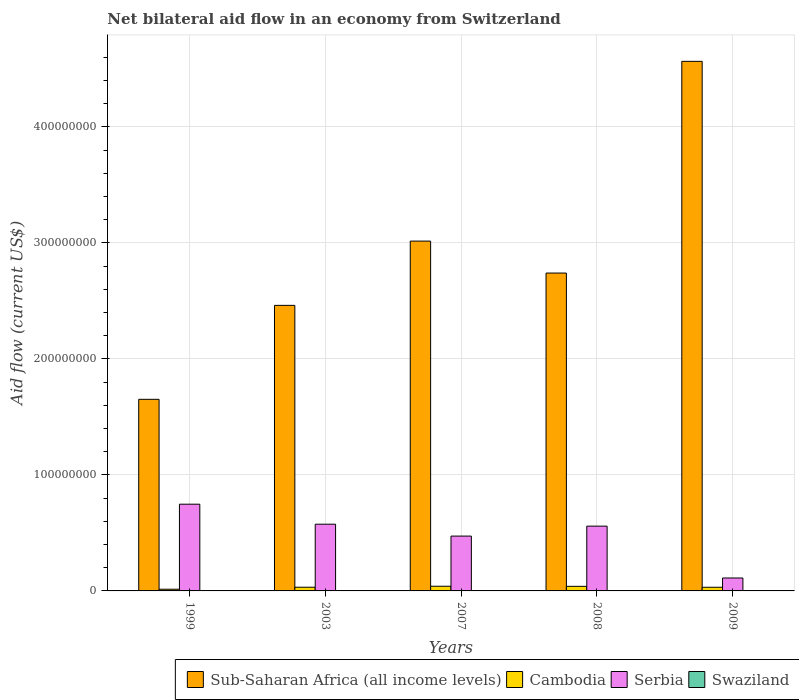How many different coloured bars are there?
Your answer should be very brief. 4. How many groups of bars are there?
Make the answer very short. 5. Are the number of bars per tick equal to the number of legend labels?
Your answer should be compact. Yes. Are the number of bars on each tick of the X-axis equal?
Keep it short and to the point. Yes. How many bars are there on the 5th tick from the left?
Provide a succinct answer. 4. What is the label of the 2nd group of bars from the left?
Give a very brief answer. 2003. What is the net bilateral aid flow in Serbia in 2007?
Make the answer very short. 4.73e+07. Across all years, what is the maximum net bilateral aid flow in Cambodia?
Keep it short and to the point. 4.03e+06. Across all years, what is the minimum net bilateral aid flow in Swaziland?
Offer a terse response. 2.00e+04. In which year was the net bilateral aid flow in Swaziland maximum?
Your answer should be compact. 2008. In which year was the net bilateral aid flow in Sub-Saharan Africa (all income levels) minimum?
Offer a terse response. 1999. What is the total net bilateral aid flow in Sub-Saharan Africa (all income levels) in the graph?
Offer a very short reply. 1.44e+09. What is the difference between the net bilateral aid flow in Cambodia in 2007 and that in 2009?
Your answer should be very brief. 8.70e+05. What is the difference between the net bilateral aid flow in Sub-Saharan Africa (all income levels) in 2003 and the net bilateral aid flow in Serbia in 1999?
Your answer should be very brief. 1.71e+08. What is the average net bilateral aid flow in Cambodia per year?
Your answer should be very brief. 3.16e+06. In the year 2003, what is the difference between the net bilateral aid flow in Sub-Saharan Africa (all income levels) and net bilateral aid flow in Swaziland?
Provide a succinct answer. 2.46e+08. What is the ratio of the net bilateral aid flow in Serbia in 2003 to that in 2007?
Keep it short and to the point. 1.22. In how many years, is the net bilateral aid flow in Sub-Saharan Africa (all income levels) greater than the average net bilateral aid flow in Sub-Saharan Africa (all income levels) taken over all years?
Provide a short and direct response. 2. Is the sum of the net bilateral aid flow in Swaziland in 1999 and 2009 greater than the maximum net bilateral aid flow in Cambodia across all years?
Your answer should be very brief. No. Is it the case that in every year, the sum of the net bilateral aid flow in Sub-Saharan Africa (all income levels) and net bilateral aid flow in Cambodia is greater than the sum of net bilateral aid flow in Serbia and net bilateral aid flow in Swaziland?
Offer a very short reply. Yes. What does the 3rd bar from the left in 2008 represents?
Offer a terse response. Serbia. What does the 3rd bar from the right in 2008 represents?
Offer a very short reply. Cambodia. How many bars are there?
Offer a very short reply. 20. Does the graph contain any zero values?
Give a very brief answer. No. Does the graph contain grids?
Ensure brevity in your answer.  Yes. How many legend labels are there?
Keep it short and to the point. 4. How are the legend labels stacked?
Provide a succinct answer. Horizontal. What is the title of the graph?
Your answer should be very brief. Net bilateral aid flow in an economy from Switzerland. What is the label or title of the X-axis?
Your answer should be very brief. Years. What is the Aid flow (current US$) of Sub-Saharan Africa (all income levels) in 1999?
Your answer should be very brief. 1.65e+08. What is the Aid flow (current US$) in Cambodia in 1999?
Offer a very short reply. 1.46e+06. What is the Aid flow (current US$) in Serbia in 1999?
Provide a short and direct response. 7.48e+07. What is the Aid flow (current US$) of Sub-Saharan Africa (all income levels) in 2003?
Offer a very short reply. 2.46e+08. What is the Aid flow (current US$) in Cambodia in 2003?
Make the answer very short. 3.19e+06. What is the Aid flow (current US$) in Serbia in 2003?
Give a very brief answer. 5.75e+07. What is the Aid flow (current US$) in Swaziland in 2003?
Your answer should be compact. 7.00e+04. What is the Aid flow (current US$) in Sub-Saharan Africa (all income levels) in 2007?
Your answer should be compact. 3.02e+08. What is the Aid flow (current US$) of Cambodia in 2007?
Provide a succinct answer. 4.03e+06. What is the Aid flow (current US$) in Serbia in 2007?
Keep it short and to the point. 4.73e+07. What is the Aid flow (current US$) in Swaziland in 2007?
Keep it short and to the point. 2.00e+04. What is the Aid flow (current US$) in Sub-Saharan Africa (all income levels) in 2008?
Provide a succinct answer. 2.74e+08. What is the Aid flow (current US$) in Cambodia in 2008?
Offer a terse response. 3.95e+06. What is the Aid flow (current US$) in Serbia in 2008?
Keep it short and to the point. 5.58e+07. What is the Aid flow (current US$) of Sub-Saharan Africa (all income levels) in 2009?
Your response must be concise. 4.56e+08. What is the Aid flow (current US$) of Cambodia in 2009?
Provide a succinct answer. 3.16e+06. What is the Aid flow (current US$) of Serbia in 2009?
Offer a terse response. 1.12e+07. What is the Aid flow (current US$) of Swaziland in 2009?
Offer a terse response. 2.00e+04. Across all years, what is the maximum Aid flow (current US$) of Sub-Saharan Africa (all income levels)?
Your answer should be compact. 4.56e+08. Across all years, what is the maximum Aid flow (current US$) in Cambodia?
Your answer should be very brief. 4.03e+06. Across all years, what is the maximum Aid flow (current US$) in Serbia?
Ensure brevity in your answer.  7.48e+07. Across all years, what is the maximum Aid flow (current US$) of Swaziland?
Offer a very short reply. 1.40e+05. Across all years, what is the minimum Aid flow (current US$) of Sub-Saharan Africa (all income levels)?
Your response must be concise. 1.65e+08. Across all years, what is the minimum Aid flow (current US$) in Cambodia?
Give a very brief answer. 1.46e+06. Across all years, what is the minimum Aid flow (current US$) of Serbia?
Make the answer very short. 1.12e+07. What is the total Aid flow (current US$) of Sub-Saharan Africa (all income levels) in the graph?
Your response must be concise. 1.44e+09. What is the total Aid flow (current US$) of Cambodia in the graph?
Provide a short and direct response. 1.58e+07. What is the total Aid flow (current US$) of Serbia in the graph?
Your response must be concise. 2.47e+08. What is the difference between the Aid flow (current US$) in Sub-Saharan Africa (all income levels) in 1999 and that in 2003?
Give a very brief answer. -8.10e+07. What is the difference between the Aid flow (current US$) of Cambodia in 1999 and that in 2003?
Make the answer very short. -1.73e+06. What is the difference between the Aid flow (current US$) of Serbia in 1999 and that in 2003?
Your answer should be compact. 1.72e+07. What is the difference between the Aid flow (current US$) in Sub-Saharan Africa (all income levels) in 1999 and that in 2007?
Your answer should be compact. -1.36e+08. What is the difference between the Aid flow (current US$) of Cambodia in 1999 and that in 2007?
Give a very brief answer. -2.57e+06. What is the difference between the Aid flow (current US$) in Serbia in 1999 and that in 2007?
Your answer should be compact. 2.75e+07. What is the difference between the Aid flow (current US$) of Sub-Saharan Africa (all income levels) in 1999 and that in 2008?
Your answer should be very brief. -1.09e+08. What is the difference between the Aid flow (current US$) of Cambodia in 1999 and that in 2008?
Your response must be concise. -2.49e+06. What is the difference between the Aid flow (current US$) of Serbia in 1999 and that in 2008?
Your answer should be compact. 1.89e+07. What is the difference between the Aid flow (current US$) in Swaziland in 1999 and that in 2008?
Give a very brief answer. -1.00e+05. What is the difference between the Aid flow (current US$) of Sub-Saharan Africa (all income levels) in 1999 and that in 2009?
Give a very brief answer. -2.91e+08. What is the difference between the Aid flow (current US$) of Cambodia in 1999 and that in 2009?
Make the answer very short. -1.70e+06. What is the difference between the Aid flow (current US$) in Serbia in 1999 and that in 2009?
Your answer should be very brief. 6.36e+07. What is the difference between the Aid flow (current US$) in Swaziland in 1999 and that in 2009?
Keep it short and to the point. 2.00e+04. What is the difference between the Aid flow (current US$) in Sub-Saharan Africa (all income levels) in 2003 and that in 2007?
Offer a very short reply. -5.54e+07. What is the difference between the Aid flow (current US$) of Cambodia in 2003 and that in 2007?
Your answer should be very brief. -8.40e+05. What is the difference between the Aid flow (current US$) in Serbia in 2003 and that in 2007?
Your answer should be compact. 1.02e+07. What is the difference between the Aid flow (current US$) in Swaziland in 2003 and that in 2007?
Offer a terse response. 5.00e+04. What is the difference between the Aid flow (current US$) in Sub-Saharan Africa (all income levels) in 2003 and that in 2008?
Keep it short and to the point. -2.79e+07. What is the difference between the Aid flow (current US$) of Cambodia in 2003 and that in 2008?
Ensure brevity in your answer.  -7.60e+05. What is the difference between the Aid flow (current US$) in Serbia in 2003 and that in 2008?
Offer a very short reply. 1.67e+06. What is the difference between the Aid flow (current US$) in Swaziland in 2003 and that in 2008?
Provide a succinct answer. -7.00e+04. What is the difference between the Aid flow (current US$) in Sub-Saharan Africa (all income levels) in 2003 and that in 2009?
Offer a very short reply. -2.10e+08. What is the difference between the Aid flow (current US$) of Serbia in 2003 and that in 2009?
Provide a short and direct response. 4.64e+07. What is the difference between the Aid flow (current US$) in Swaziland in 2003 and that in 2009?
Provide a succinct answer. 5.00e+04. What is the difference between the Aid flow (current US$) in Sub-Saharan Africa (all income levels) in 2007 and that in 2008?
Your response must be concise. 2.75e+07. What is the difference between the Aid flow (current US$) in Cambodia in 2007 and that in 2008?
Give a very brief answer. 8.00e+04. What is the difference between the Aid flow (current US$) in Serbia in 2007 and that in 2008?
Your answer should be very brief. -8.58e+06. What is the difference between the Aid flow (current US$) of Sub-Saharan Africa (all income levels) in 2007 and that in 2009?
Offer a very short reply. -1.55e+08. What is the difference between the Aid flow (current US$) in Cambodia in 2007 and that in 2009?
Your answer should be very brief. 8.70e+05. What is the difference between the Aid flow (current US$) in Serbia in 2007 and that in 2009?
Make the answer very short. 3.61e+07. What is the difference between the Aid flow (current US$) of Swaziland in 2007 and that in 2009?
Your answer should be compact. 0. What is the difference between the Aid flow (current US$) in Sub-Saharan Africa (all income levels) in 2008 and that in 2009?
Offer a very short reply. -1.82e+08. What is the difference between the Aid flow (current US$) of Cambodia in 2008 and that in 2009?
Make the answer very short. 7.90e+05. What is the difference between the Aid flow (current US$) of Serbia in 2008 and that in 2009?
Provide a short and direct response. 4.47e+07. What is the difference between the Aid flow (current US$) of Sub-Saharan Africa (all income levels) in 1999 and the Aid flow (current US$) of Cambodia in 2003?
Offer a very short reply. 1.62e+08. What is the difference between the Aid flow (current US$) in Sub-Saharan Africa (all income levels) in 1999 and the Aid flow (current US$) in Serbia in 2003?
Offer a terse response. 1.08e+08. What is the difference between the Aid flow (current US$) of Sub-Saharan Africa (all income levels) in 1999 and the Aid flow (current US$) of Swaziland in 2003?
Offer a terse response. 1.65e+08. What is the difference between the Aid flow (current US$) in Cambodia in 1999 and the Aid flow (current US$) in Serbia in 2003?
Offer a very short reply. -5.61e+07. What is the difference between the Aid flow (current US$) of Cambodia in 1999 and the Aid flow (current US$) of Swaziland in 2003?
Offer a terse response. 1.39e+06. What is the difference between the Aid flow (current US$) in Serbia in 1999 and the Aid flow (current US$) in Swaziland in 2003?
Ensure brevity in your answer.  7.47e+07. What is the difference between the Aid flow (current US$) in Sub-Saharan Africa (all income levels) in 1999 and the Aid flow (current US$) in Cambodia in 2007?
Offer a very short reply. 1.61e+08. What is the difference between the Aid flow (current US$) in Sub-Saharan Africa (all income levels) in 1999 and the Aid flow (current US$) in Serbia in 2007?
Offer a terse response. 1.18e+08. What is the difference between the Aid flow (current US$) of Sub-Saharan Africa (all income levels) in 1999 and the Aid flow (current US$) of Swaziland in 2007?
Provide a short and direct response. 1.65e+08. What is the difference between the Aid flow (current US$) of Cambodia in 1999 and the Aid flow (current US$) of Serbia in 2007?
Provide a succinct answer. -4.58e+07. What is the difference between the Aid flow (current US$) in Cambodia in 1999 and the Aid flow (current US$) in Swaziland in 2007?
Your answer should be very brief. 1.44e+06. What is the difference between the Aid flow (current US$) of Serbia in 1999 and the Aid flow (current US$) of Swaziland in 2007?
Offer a terse response. 7.47e+07. What is the difference between the Aid flow (current US$) in Sub-Saharan Africa (all income levels) in 1999 and the Aid flow (current US$) in Cambodia in 2008?
Give a very brief answer. 1.61e+08. What is the difference between the Aid flow (current US$) in Sub-Saharan Africa (all income levels) in 1999 and the Aid flow (current US$) in Serbia in 2008?
Provide a short and direct response. 1.09e+08. What is the difference between the Aid flow (current US$) in Sub-Saharan Africa (all income levels) in 1999 and the Aid flow (current US$) in Swaziland in 2008?
Offer a terse response. 1.65e+08. What is the difference between the Aid flow (current US$) in Cambodia in 1999 and the Aid flow (current US$) in Serbia in 2008?
Offer a terse response. -5.44e+07. What is the difference between the Aid flow (current US$) in Cambodia in 1999 and the Aid flow (current US$) in Swaziland in 2008?
Offer a very short reply. 1.32e+06. What is the difference between the Aid flow (current US$) in Serbia in 1999 and the Aid flow (current US$) in Swaziland in 2008?
Offer a terse response. 7.46e+07. What is the difference between the Aid flow (current US$) in Sub-Saharan Africa (all income levels) in 1999 and the Aid flow (current US$) in Cambodia in 2009?
Your response must be concise. 1.62e+08. What is the difference between the Aid flow (current US$) in Sub-Saharan Africa (all income levels) in 1999 and the Aid flow (current US$) in Serbia in 2009?
Provide a succinct answer. 1.54e+08. What is the difference between the Aid flow (current US$) of Sub-Saharan Africa (all income levels) in 1999 and the Aid flow (current US$) of Swaziland in 2009?
Provide a succinct answer. 1.65e+08. What is the difference between the Aid flow (current US$) in Cambodia in 1999 and the Aid flow (current US$) in Serbia in 2009?
Provide a short and direct response. -9.69e+06. What is the difference between the Aid flow (current US$) of Cambodia in 1999 and the Aid flow (current US$) of Swaziland in 2009?
Make the answer very short. 1.44e+06. What is the difference between the Aid flow (current US$) of Serbia in 1999 and the Aid flow (current US$) of Swaziland in 2009?
Keep it short and to the point. 7.47e+07. What is the difference between the Aid flow (current US$) in Sub-Saharan Africa (all income levels) in 2003 and the Aid flow (current US$) in Cambodia in 2007?
Your response must be concise. 2.42e+08. What is the difference between the Aid flow (current US$) of Sub-Saharan Africa (all income levels) in 2003 and the Aid flow (current US$) of Serbia in 2007?
Make the answer very short. 1.99e+08. What is the difference between the Aid flow (current US$) of Sub-Saharan Africa (all income levels) in 2003 and the Aid flow (current US$) of Swaziland in 2007?
Provide a short and direct response. 2.46e+08. What is the difference between the Aid flow (current US$) in Cambodia in 2003 and the Aid flow (current US$) in Serbia in 2007?
Your response must be concise. -4.41e+07. What is the difference between the Aid flow (current US$) of Cambodia in 2003 and the Aid flow (current US$) of Swaziland in 2007?
Provide a succinct answer. 3.17e+06. What is the difference between the Aid flow (current US$) in Serbia in 2003 and the Aid flow (current US$) in Swaziland in 2007?
Keep it short and to the point. 5.75e+07. What is the difference between the Aid flow (current US$) of Sub-Saharan Africa (all income levels) in 2003 and the Aid flow (current US$) of Cambodia in 2008?
Ensure brevity in your answer.  2.42e+08. What is the difference between the Aid flow (current US$) in Sub-Saharan Africa (all income levels) in 2003 and the Aid flow (current US$) in Serbia in 2008?
Offer a terse response. 1.90e+08. What is the difference between the Aid flow (current US$) in Sub-Saharan Africa (all income levels) in 2003 and the Aid flow (current US$) in Swaziland in 2008?
Offer a terse response. 2.46e+08. What is the difference between the Aid flow (current US$) of Cambodia in 2003 and the Aid flow (current US$) of Serbia in 2008?
Your answer should be compact. -5.27e+07. What is the difference between the Aid flow (current US$) in Cambodia in 2003 and the Aid flow (current US$) in Swaziland in 2008?
Ensure brevity in your answer.  3.05e+06. What is the difference between the Aid flow (current US$) in Serbia in 2003 and the Aid flow (current US$) in Swaziland in 2008?
Provide a succinct answer. 5.74e+07. What is the difference between the Aid flow (current US$) in Sub-Saharan Africa (all income levels) in 2003 and the Aid flow (current US$) in Cambodia in 2009?
Keep it short and to the point. 2.43e+08. What is the difference between the Aid flow (current US$) of Sub-Saharan Africa (all income levels) in 2003 and the Aid flow (current US$) of Serbia in 2009?
Offer a terse response. 2.35e+08. What is the difference between the Aid flow (current US$) of Sub-Saharan Africa (all income levels) in 2003 and the Aid flow (current US$) of Swaziland in 2009?
Offer a very short reply. 2.46e+08. What is the difference between the Aid flow (current US$) of Cambodia in 2003 and the Aid flow (current US$) of Serbia in 2009?
Offer a very short reply. -7.96e+06. What is the difference between the Aid flow (current US$) of Cambodia in 2003 and the Aid flow (current US$) of Swaziland in 2009?
Provide a succinct answer. 3.17e+06. What is the difference between the Aid flow (current US$) in Serbia in 2003 and the Aid flow (current US$) in Swaziland in 2009?
Your response must be concise. 5.75e+07. What is the difference between the Aid flow (current US$) in Sub-Saharan Africa (all income levels) in 2007 and the Aid flow (current US$) in Cambodia in 2008?
Your answer should be very brief. 2.98e+08. What is the difference between the Aid flow (current US$) in Sub-Saharan Africa (all income levels) in 2007 and the Aid flow (current US$) in Serbia in 2008?
Your answer should be compact. 2.46e+08. What is the difference between the Aid flow (current US$) in Sub-Saharan Africa (all income levels) in 2007 and the Aid flow (current US$) in Swaziland in 2008?
Provide a succinct answer. 3.01e+08. What is the difference between the Aid flow (current US$) of Cambodia in 2007 and the Aid flow (current US$) of Serbia in 2008?
Give a very brief answer. -5.18e+07. What is the difference between the Aid flow (current US$) of Cambodia in 2007 and the Aid flow (current US$) of Swaziland in 2008?
Your answer should be compact. 3.89e+06. What is the difference between the Aid flow (current US$) in Serbia in 2007 and the Aid flow (current US$) in Swaziland in 2008?
Make the answer very short. 4.71e+07. What is the difference between the Aid flow (current US$) in Sub-Saharan Africa (all income levels) in 2007 and the Aid flow (current US$) in Cambodia in 2009?
Offer a terse response. 2.98e+08. What is the difference between the Aid flow (current US$) in Sub-Saharan Africa (all income levels) in 2007 and the Aid flow (current US$) in Serbia in 2009?
Keep it short and to the point. 2.90e+08. What is the difference between the Aid flow (current US$) of Sub-Saharan Africa (all income levels) in 2007 and the Aid flow (current US$) of Swaziland in 2009?
Give a very brief answer. 3.02e+08. What is the difference between the Aid flow (current US$) in Cambodia in 2007 and the Aid flow (current US$) in Serbia in 2009?
Provide a short and direct response. -7.12e+06. What is the difference between the Aid flow (current US$) of Cambodia in 2007 and the Aid flow (current US$) of Swaziland in 2009?
Offer a very short reply. 4.01e+06. What is the difference between the Aid flow (current US$) of Serbia in 2007 and the Aid flow (current US$) of Swaziland in 2009?
Provide a succinct answer. 4.72e+07. What is the difference between the Aid flow (current US$) in Sub-Saharan Africa (all income levels) in 2008 and the Aid flow (current US$) in Cambodia in 2009?
Provide a short and direct response. 2.71e+08. What is the difference between the Aid flow (current US$) of Sub-Saharan Africa (all income levels) in 2008 and the Aid flow (current US$) of Serbia in 2009?
Your answer should be compact. 2.63e+08. What is the difference between the Aid flow (current US$) of Sub-Saharan Africa (all income levels) in 2008 and the Aid flow (current US$) of Swaziland in 2009?
Your response must be concise. 2.74e+08. What is the difference between the Aid flow (current US$) of Cambodia in 2008 and the Aid flow (current US$) of Serbia in 2009?
Offer a very short reply. -7.20e+06. What is the difference between the Aid flow (current US$) of Cambodia in 2008 and the Aid flow (current US$) of Swaziland in 2009?
Offer a very short reply. 3.93e+06. What is the difference between the Aid flow (current US$) of Serbia in 2008 and the Aid flow (current US$) of Swaziland in 2009?
Make the answer very short. 5.58e+07. What is the average Aid flow (current US$) of Sub-Saharan Africa (all income levels) per year?
Offer a very short reply. 2.89e+08. What is the average Aid flow (current US$) in Cambodia per year?
Your response must be concise. 3.16e+06. What is the average Aid flow (current US$) in Serbia per year?
Offer a very short reply. 4.93e+07. What is the average Aid flow (current US$) in Swaziland per year?
Make the answer very short. 5.80e+04. In the year 1999, what is the difference between the Aid flow (current US$) in Sub-Saharan Africa (all income levels) and Aid flow (current US$) in Cambodia?
Ensure brevity in your answer.  1.64e+08. In the year 1999, what is the difference between the Aid flow (current US$) of Sub-Saharan Africa (all income levels) and Aid flow (current US$) of Serbia?
Keep it short and to the point. 9.04e+07. In the year 1999, what is the difference between the Aid flow (current US$) in Sub-Saharan Africa (all income levels) and Aid flow (current US$) in Swaziland?
Make the answer very short. 1.65e+08. In the year 1999, what is the difference between the Aid flow (current US$) of Cambodia and Aid flow (current US$) of Serbia?
Make the answer very short. -7.33e+07. In the year 1999, what is the difference between the Aid flow (current US$) in Cambodia and Aid flow (current US$) in Swaziland?
Make the answer very short. 1.42e+06. In the year 1999, what is the difference between the Aid flow (current US$) in Serbia and Aid flow (current US$) in Swaziland?
Offer a terse response. 7.47e+07. In the year 2003, what is the difference between the Aid flow (current US$) of Sub-Saharan Africa (all income levels) and Aid flow (current US$) of Cambodia?
Your answer should be very brief. 2.43e+08. In the year 2003, what is the difference between the Aid flow (current US$) in Sub-Saharan Africa (all income levels) and Aid flow (current US$) in Serbia?
Provide a succinct answer. 1.89e+08. In the year 2003, what is the difference between the Aid flow (current US$) in Sub-Saharan Africa (all income levels) and Aid flow (current US$) in Swaziland?
Provide a succinct answer. 2.46e+08. In the year 2003, what is the difference between the Aid flow (current US$) in Cambodia and Aid flow (current US$) in Serbia?
Keep it short and to the point. -5.43e+07. In the year 2003, what is the difference between the Aid flow (current US$) of Cambodia and Aid flow (current US$) of Swaziland?
Offer a very short reply. 3.12e+06. In the year 2003, what is the difference between the Aid flow (current US$) in Serbia and Aid flow (current US$) in Swaziland?
Offer a terse response. 5.74e+07. In the year 2007, what is the difference between the Aid flow (current US$) of Sub-Saharan Africa (all income levels) and Aid flow (current US$) of Cambodia?
Make the answer very short. 2.98e+08. In the year 2007, what is the difference between the Aid flow (current US$) of Sub-Saharan Africa (all income levels) and Aid flow (current US$) of Serbia?
Give a very brief answer. 2.54e+08. In the year 2007, what is the difference between the Aid flow (current US$) in Sub-Saharan Africa (all income levels) and Aid flow (current US$) in Swaziland?
Provide a short and direct response. 3.02e+08. In the year 2007, what is the difference between the Aid flow (current US$) of Cambodia and Aid flow (current US$) of Serbia?
Provide a short and direct response. -4.32e+07. In the year 2007, what is the difference between the Aid flow (current US$) of Cambodia and Aid flow (current US$) of Swaziland?
Provide a short and direct response. 4.01e+06. In the year 2007, what is the difference between the Aid flow (current US$) in Serbia and Aid flow (current US$) in Swaziland?
Your answer should be compact. 4.72e+07. In the year 2008, what is the difference between the Aid flow (current US$) of Sub-Saharan Africa (all income levels) and Aid flow (current US$) of Cambodia?
Make the answer very short. 2.70e+08. In the year 2008, what is the difference between the Aid flow (current US$) of Sub-Saharan Africa (all income levels) and Aid flow (current US$) of Serbia?
Your answer should be compact. 2.18e+08. In the year 2008, what is the difference between the Aid flow (current US$) in Sub-Saharan Africa (all income levels) and Aid flow (current US$) in Swaziland?
Make the answer very short. 2.74e+08. In the year 2008, what is the difference between the Aid flow (current US$) in Cambodia and Aid flow (current US$) in Serbia?
Provide a succinct answer. -5.19e+07. In the year 2008, what is the difference between the Aid flow (current US$) of Cambodia and Aid flow (current US$) of Swaziland?
Provide a succinct answer. 3.81e+06. In the year 2008, what is the difference between the Aid flow (current US$) in Serbia and Aid flow (current US$) in Swaziland?
Give a very brief answer. 5.57e+07. In the year 2009, what is the difference between the Aid flow (current US$) of Sub-Saharan Africa (all income levels) and Aid flow (current US$) of Cambodia?
Your answer should be very brief. 4.53e+08. In the year 2009, what is the difference between the Aid flow (current US$) in Sub-Saharan Africa (all income levels) and Aid flow (current US$) in Serbia?
Your answer should be very brief. 4.45e+08. In the year 2009, what is the difference between the Aid flow (current US$) of Sub-Saharan Africa (all income levels) and Aid flow (current US$) of Swaziland?
Provide a short and direct response. 4.56e+08. In the year 2009, what is the difference between the Aid flow (current US$) of Cambodia and Aid flow (current US$) of Serbia?
Your response must be concise. -7.99e+06. In the year 2009, what is the difference between the Aid flow (current US$) in Cambodia and Aid flow (current US$) in Swaziland?
Ensure brevity in your answer.  3.14e+06. In the year 2009, what is the difference between the Aid flow (current US$) of Serbia and Aid flow (current US$) of Swaziland?
Give a very brief answer. 1.11e+07. What is the ratio of the Aid flow (current US$) in Sub-Saharan Africa (all income levels) in 1999 to that in 2003?
Give a very brief answer. 0.67. What is the ratio of the Aid flow (current US$) in Cambodia in 1999 to that in 2003?
Give a very brief answer. 0.46. What is the ratio of the Aid flow (current US$) in Serbia in 1999 to that in 2003?
Provide a succinct answer. 1.3. What is the ratio of the Aid flow (current US$) in Sub-Saharan Africa (all income levels) in 1999 to that in 2007?
Your answer should be compact. 0.55. What is the ratio of the Aid flow (current US$) in Cambodia in 1999 to that in 2007?
Make the answer very short. 0.36. What is the ratio of the Aid flow (current US$) in Serbia in 1999 to that in 2007?
Give a very brief answer. 1.58. What is the ratio of the Aid flow (current US$) in Sub-Saharan Africa (all income levels) in 1999 to that in 2008?
Make the answer very short. 0.6. What is the ratio of the Aid flow (current US$) in Cambodia in 1999 to that in 2008?
Offer a very short reply. 0.37. What is the ratio of the Aid flow (current US$) of Serbia in 1999 to that in 2008?
Your answer should be very brief. 1.34. What is the ratio of the Aid flow (current US$) in Swaziland in 1999 to that in 2008?
Offer a terse response. 0.29. What is the ratio of the Aid flow (current US$) of Sub-Saharan Africa (all income levels) in 1999 to that in 2009?
Your answer should be compact. 0.36. What is the ratio of the Aid flow (current US$) of Cambodia in 1999 to that in 2009?
Ensure brevity in your answer.  0.46. What is the ratio of the Aid flow (current US$) in Serbia in 1999 to that in 2009?
Ensure brevity in your answer.  6.7. What is the ratio of the Aid flow (current US$) in Sub-Saharan Africa (all income levels) in 2003 to that in 2007?
Make the answer very short. 0.82. What is the ratio of the Aid flow (current US$) of Cambodia in 2003 to that in 2007?
Provide a short and direct response. 0.79. What is the ratio of the Aid flow (current US$) in Serbia in 2003 to that in 2007?
Offer a terse response. 1.22. What is the ratio of the Aid flow (current US$) of Sub-Saharan Africa (all income levels) in 2003 to that in 2008?
Your answer should be compact. 0.9. What is the ratio of the Aid flow (current US$) of Cambodia in 2003 to that in 2008?
Give a very brief answer. 0.81. What is the ratio of the Aid flow (current US$) of Serbia in 2003 to that in 2008?
Your answer should be compact. 1.03. What is the ratio of the Aid flow (current US$) of Sub-Saharan Africa (all income levels) in 2003 to that in 2009?
Your answer should be compact. 0.54. What is the ratio of the Aid flow (current US$) in Cambodia in 2003 to that in 2009?
Your answer should be compact. 1.01. What is the ratio of the Aid flow (current US$) in Serbia in 2003 to that in 2009?
Your response must be concise. 5.16. What is the ratio of the Aid flow (current US$) in Sub-Saharan Africa (all income levels) in 2007 to that in 2008?
Provide a short and direct response. 1.1. What is the ratio of the Aid flow (current US$) of Cambodia in 2007 to that in 2008?
Your answer should be compact. 1.02. What is the ratio of the Aid flow (current US$) of Serbia in 2007 to that in 2008?
Your answer should be compact. 0.85. What is the ratio of the Aid flow (current US$) in Swaziland in 2007 to that in 2008?
Provide a succinct answer. 0.14. What is the ratio of the Aid flow (current US$) of Sub-Saharan Africa (all income levels) in 2007 to that in 2009?
Your answer should be very brief. 0.66. What is the ratio of the Aid flow (current US$) of Cambodia in 2007 to that in 2009?
Provide a succinct answer. 1.28. What is the ratio of the Aid flow (current US$) of Serbia in 2007 to that in 2009?
Your answer should be compact. 4.24. What is the ratio of the Aid flow (current US$) in Swaziland in 2007 to that in 2009?
Provide a succinct answer. 1. What is the ratio of the Aid flow (current US$) of Sub-Saharan Africa (all income levels) in 2008 to that in 2009?
Offer a terse response. 0.6. What is the ratio of the Aid flow (current US$) of Cambodia in 2008 to that in 2009?
Give a very brief answer. 1.25. What is the ratio of the Aid flow (current US$) of Serbia in 2008 to that in 2009?
Make the answer very short. 5.01. What is the ratio of the Aid flow (current US$) of Swaziland in 2008 to that in 2009?
Your answer should be compact. 7. What is the difference between the highest and the second highest Aid flow (current US$) in Sub-Saharan Africa (all income levels)?
Offer a very short reply. 1.55e+08. What is the difference between the highest and the second highest Aid flow (current US$) of Serbia?
Your response must be concise. 1.72e+07. What is the difference between the highest and the second highest Aid flow (current US$) in Swaziland?
Offer a terse response. 7.00e+04. What is the difference between the highest and the lowest Aid flow (current US$) in Sub-Saharan Africa (all income levels)?
Ensure brevity in your answer.  2.91e+08. What is the difference between the highest and the lowest Aid flow (current US$) in Cambodia?
Provide a succinct answer. 2.57e+06. What is the difference between the highest and the lowest Aid flow (current US$) in Serbia?
Ensure brevity in your answer.  6.36e+07. 